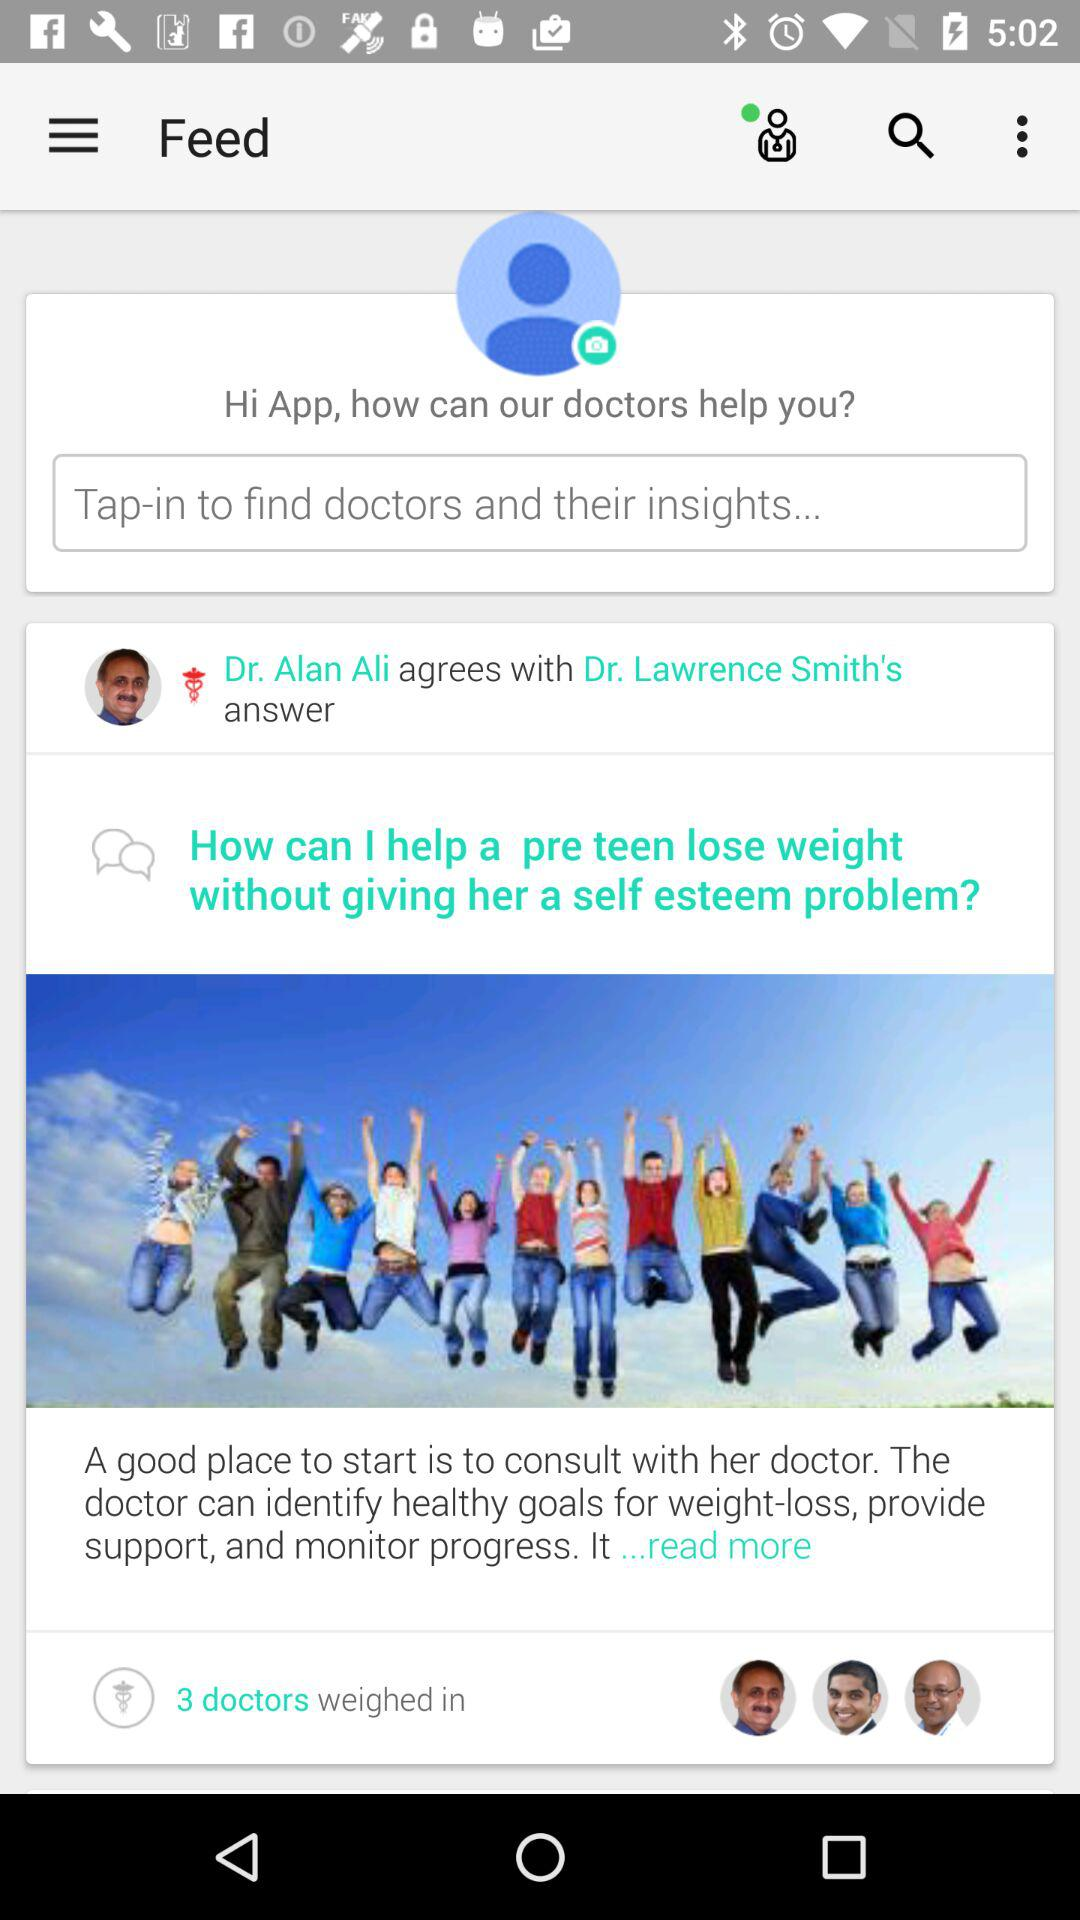How many doctors disagree with Dr. Lawrence Smith's answer?
Answer the question using a single word or phrase. 0 